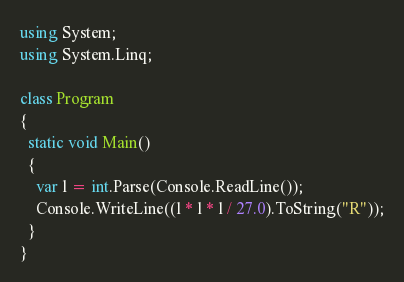<code> <loc_0><loc_0><loc_500><loc_500><_C#_>using System;
using System.Linq;

class Program
{
  static void Main()
  {
    var l = int.Parse(Console.ReadLine());
    Console.WriteLine((l * l * l / 27.0).ToString("R"));
  }
}
</code> 